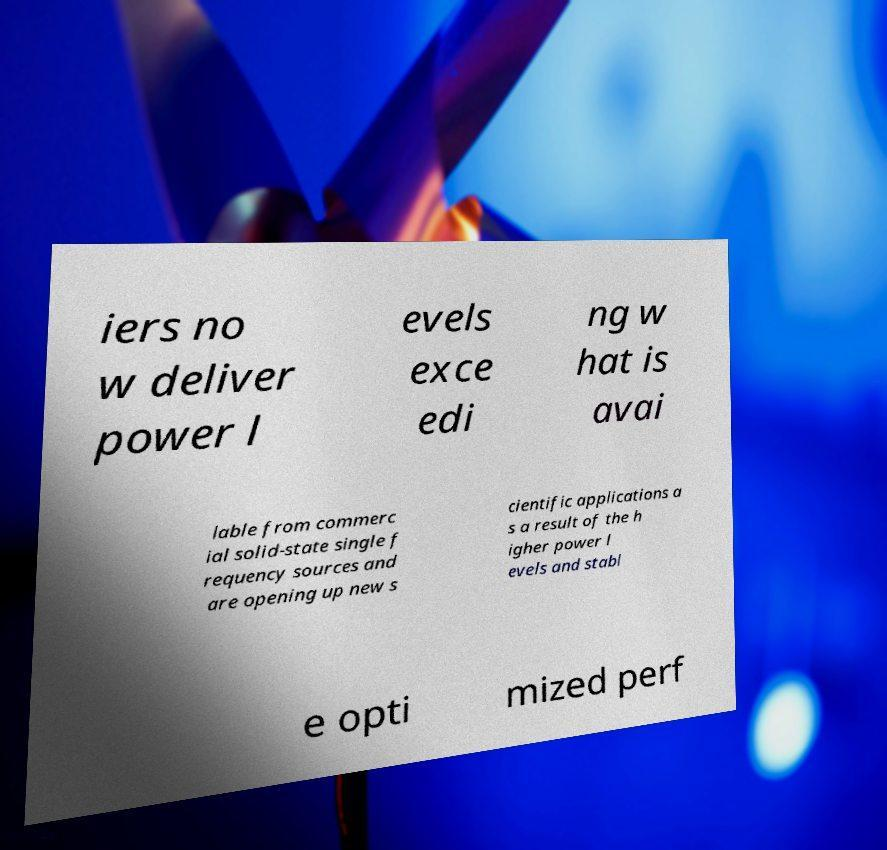Can you read and provide the text displayed in the image?This photo seems to have some interesting text. Can you extract and type it out for me? iers no w deliver power l evels exce edi ng w hat is avai lable from commerc ial solid-state single f requency sources and are opening up new s cientific applications a s a result of the h igher power l evels and stabl e opti mized perf 